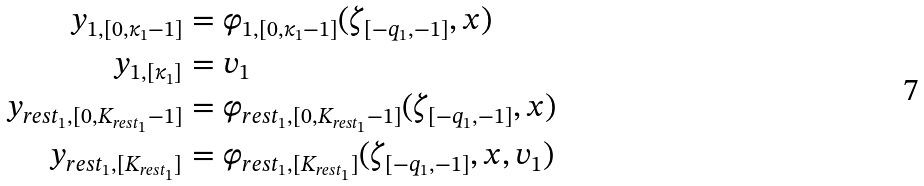<formula> <loc_0><loc_0><loc_500><loc_500>y _ { 1 , [ 0 , \kappa _ { 1 } - 1 ] } & = \varphi _ { 1 , [ 0 , \kappa _ { 1 } - 1 ] } ( \zeta _ { [ - q _ { 1 } , - 1 ] } , x ) \\ y _ { 1 , [ \kappa _ { 1 } ] } & = v _ { 1 } \\ y _ { r e s t _ { 1 } , [ 0 , K _ { r e s t _ { 1 } } - 1 ] } & = \varphi _ { r e s t _ { 1 } , [ 0 , K _ { r e s t _ { 1 } } - 1 ] } ( \zeta _ { [ - q _ { 1 } , - 1 ] } , x ) \\ y _ { r e s t _ { 1 } , [ K _ { r e s t _ { 1 } } ] } & = \varphi _ { r e s t _ { 1 } , [ K _ { r e s t _ { 1 } } ] } ( \zeta _ { [ - q _ { 1 } , - 1 ] } , x , v _ { 1 } )</formula> 